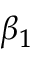<formula> <loc_0><loc_0><loc_500><loc_500>\beta _ { 1 }</formula> 